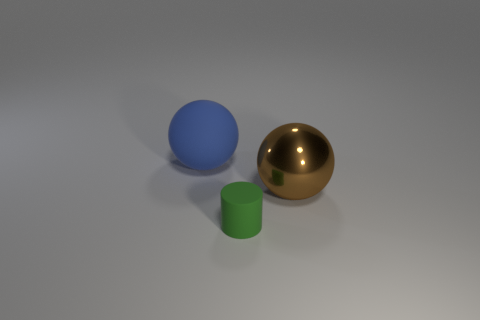Do the big ball that is on the right side of the tiny matte thing and the small matte cylinder on the right side of the rubber ball have the same color? No, they do not have the same color. The big ball to the right of the small, matte object is blue, while the small, matte cylinder to the right of the gold-colored rubber ball is green. 